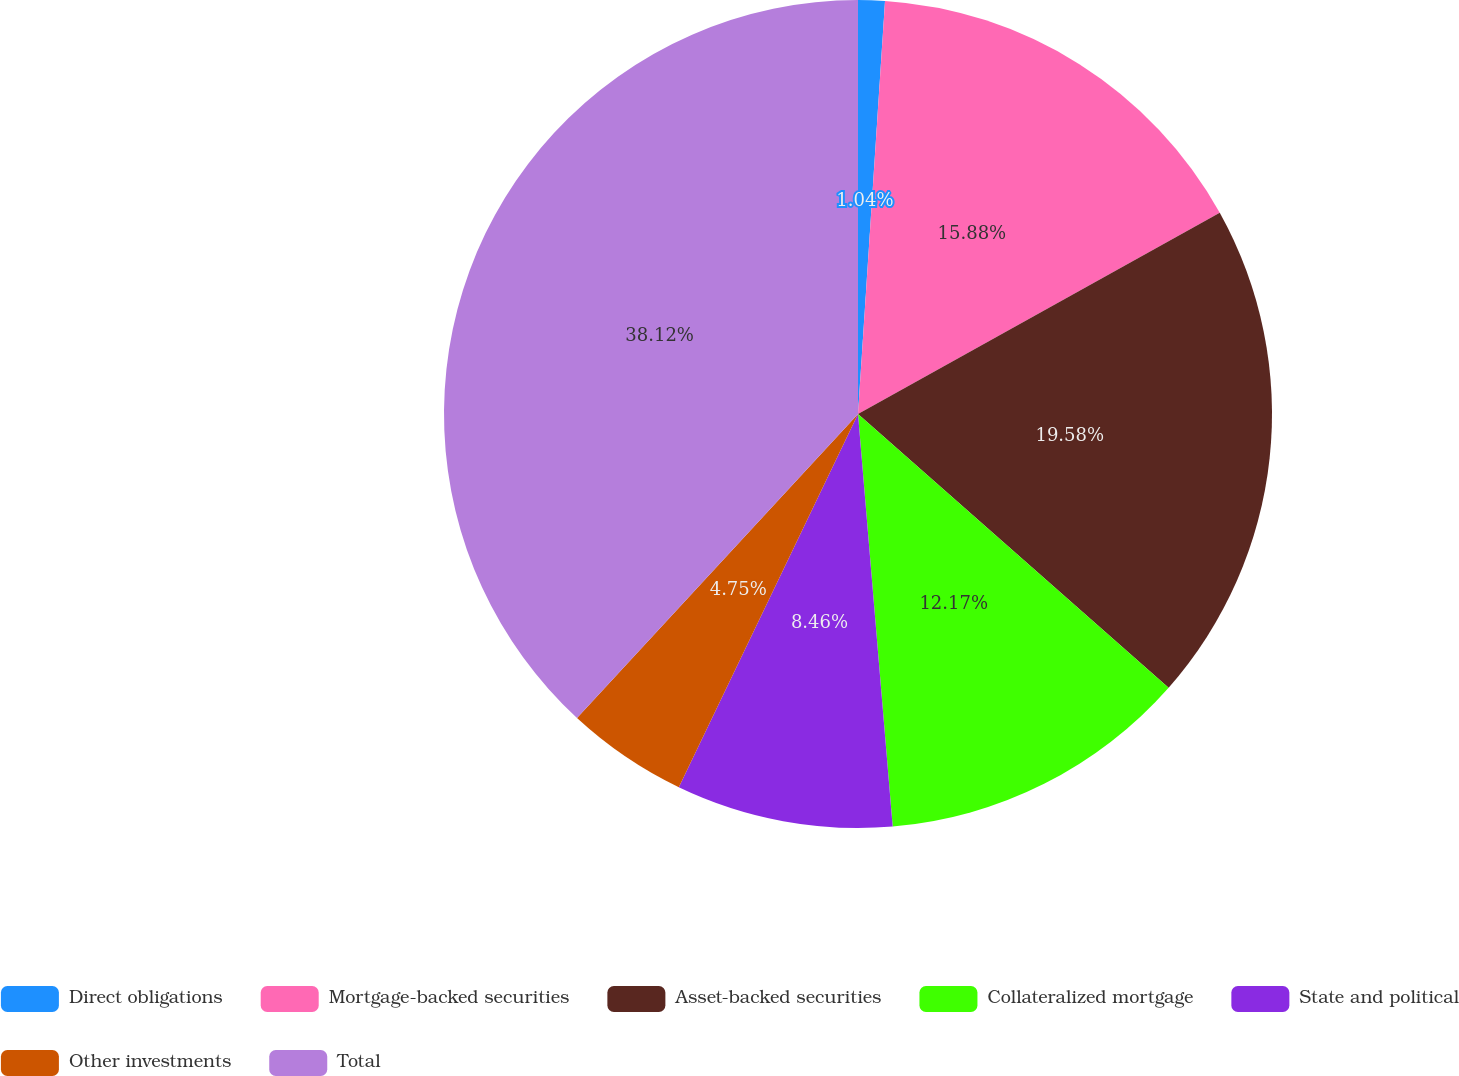Convert chart. <chart><loc_0><loc_0><loc_500><loc_500><pie_chart><fcel>Direct obligations<fcel>Mortgage-backed securities<fcel>Asset-backed securities<fcel>Collateralized mortgage<fcel>State and political<fcel>Other investments<fcel>Total<nl><fcel>1.04%<fcel>15.88%<fcel>19.58%<fcel>12.17%<fcel>8.46%<fcel>4.75%<fcel>38.13%<nl></chart> 